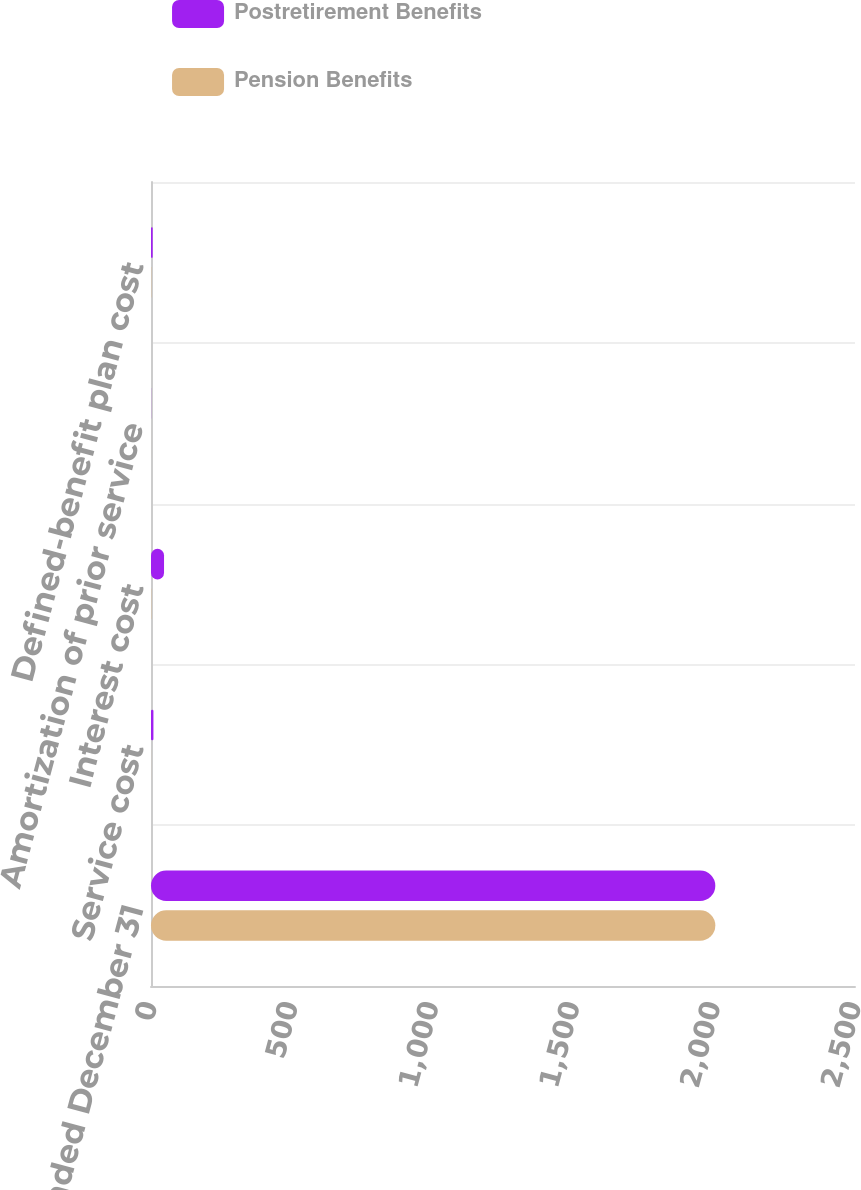Convert chart to OTSL. <chart><loc_0><loc_0><loc_500><loc_500><stacked_bar_chart><ecel><fcel>Years ended December 31<fcel>Service cost<fcel>Interest cost<fcel>Amortization of prior service<fcel>Defined-benefit plan cost<nl><fcel>Postretirement Benefits<fcel>2004<fcel>8.6<fcel>46.3<fcel>0.4<fcel>6<nl><fcel>Pension Benefits<fcel>2004<fcel>0.2<fcel>1<fcel>0.1<fcel>1<nl></chart> 